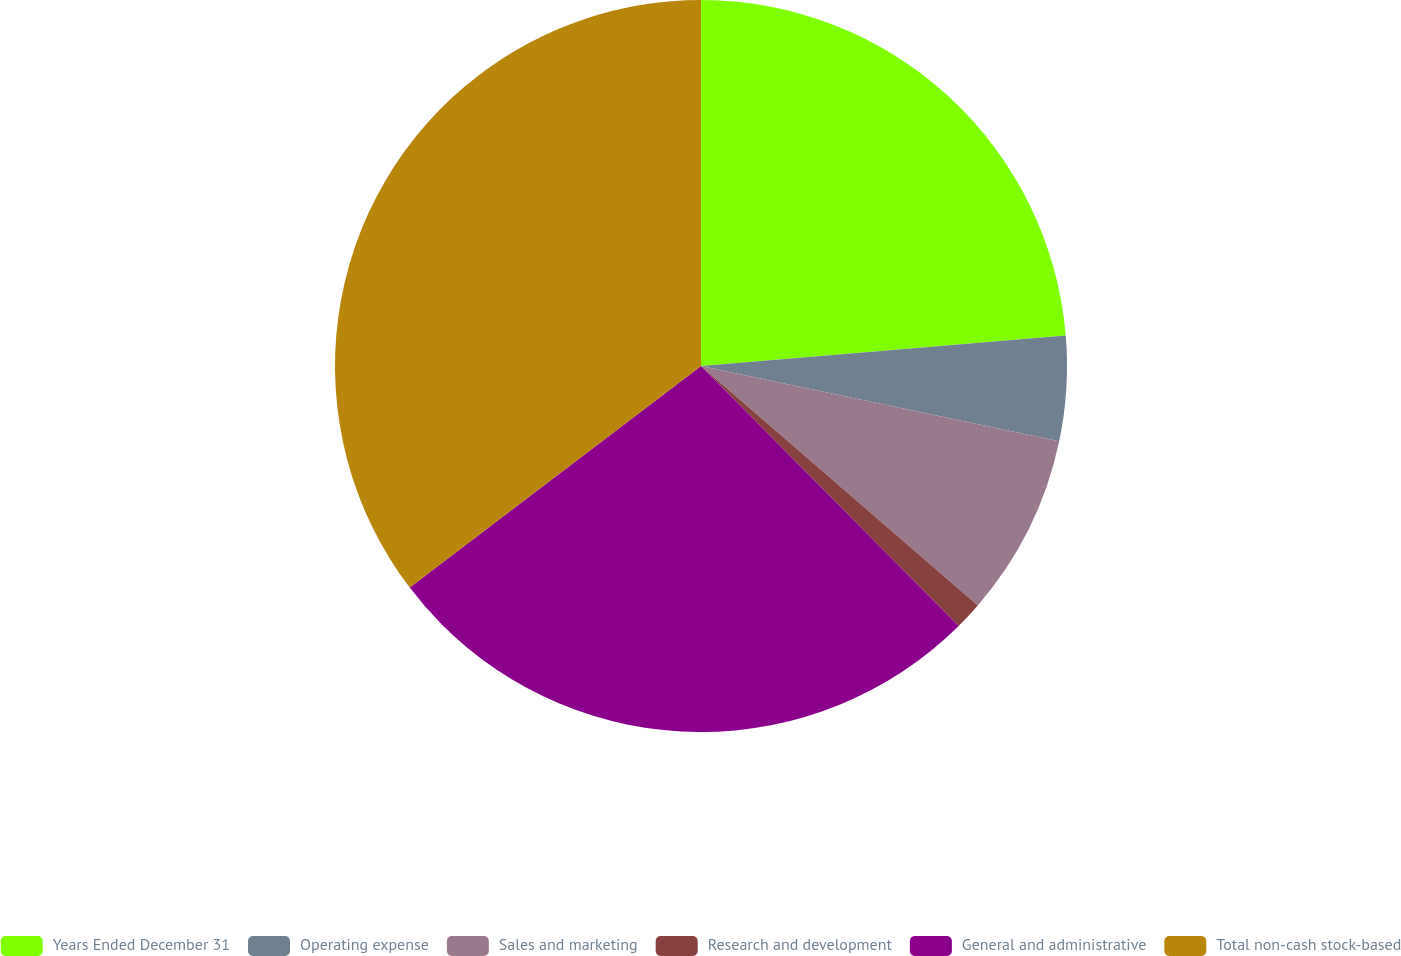Convert chart. <chart><loc_0><loc_0><loc_500><loc_500><pie_chart><fcel>Years Ended December 31<fcel>Operating expense<fcel>Sales and marketing<fcel>Research and development<fcel>General and administrative<fcel>Total non-cash stock-based<nl><fcel>23.67%<fcel>4.63%<fcel>8.05%<fcel>1.22%<fcel>27.08%<fcel>35.35%<nl></chart> 